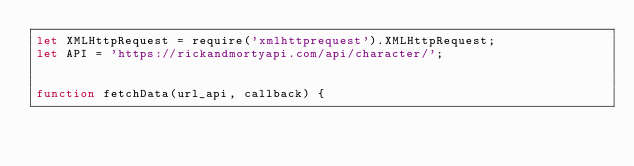Convert code to text. <code><loc_0><loc_0><loc_500><loc_500><_JavaScript_>let XMLHttpRequest = require('xmlhttprequest').XMLHttpRequest;
let API = 'https://rickandmortyapi.com/api/character/';


function fetchData(url_api, callback) {</code> 